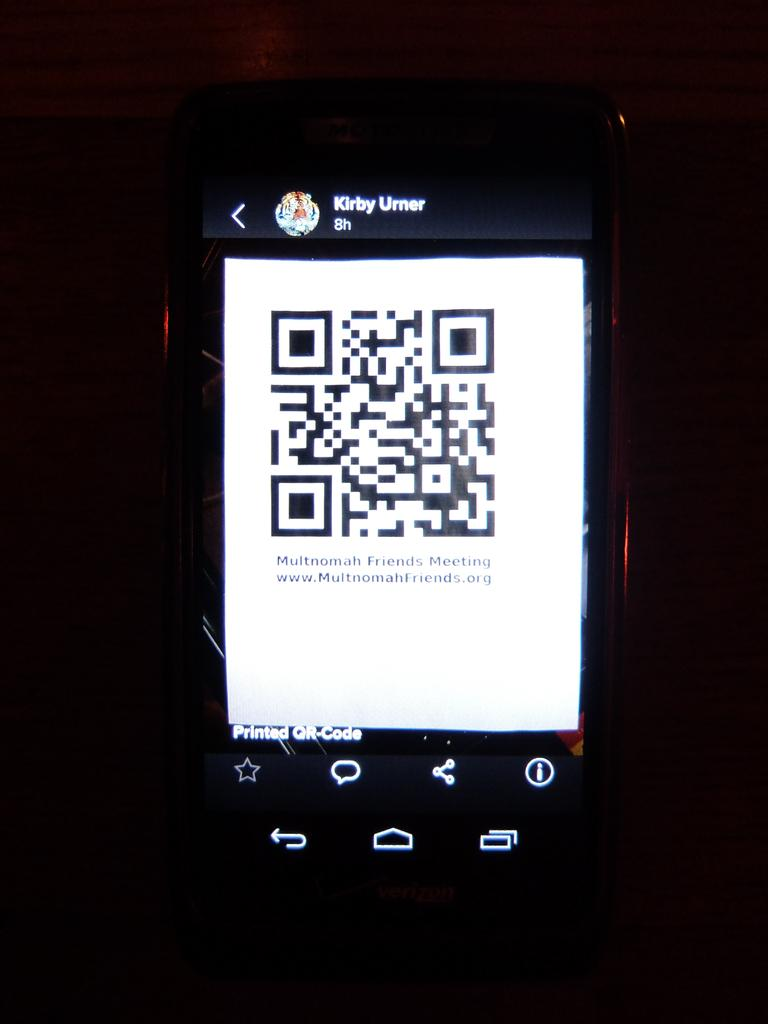<image>
Describe the image concisely. Kirby Umer shows a qr code on a cellphone 